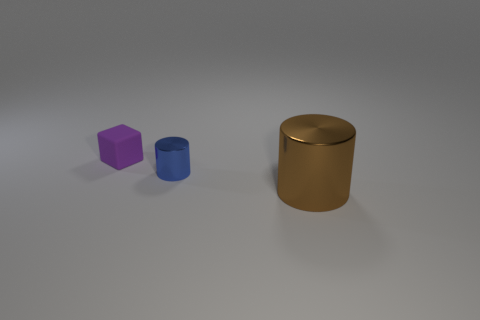What textures are present on the objects in the image? The objects exhibit matte textures which diffusely reflect light, giving them a non-glossy appearance. Specifically, there's a purple matte cube, a blue matte cylinder, and a gold matte cylinder. 